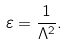Convert formula to latex. <formula><loc_0><loc_0><loc_500><loc_500>\varepsilon = \frac { 1 } { \Lambda ^ { 2 } } .</formula> 